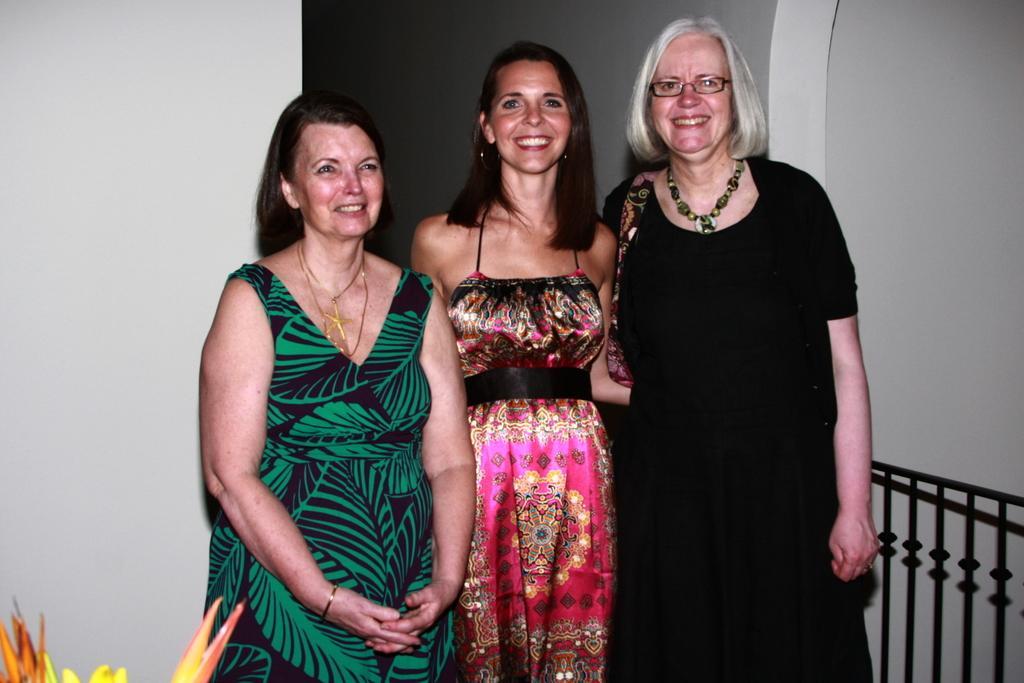Can you describe this image briefly? In the center of the picture there is a woman standing, they are having smiling faces. On the left we can see flowers and a wall painted white. On the right there is railing and at the top it is wall. 